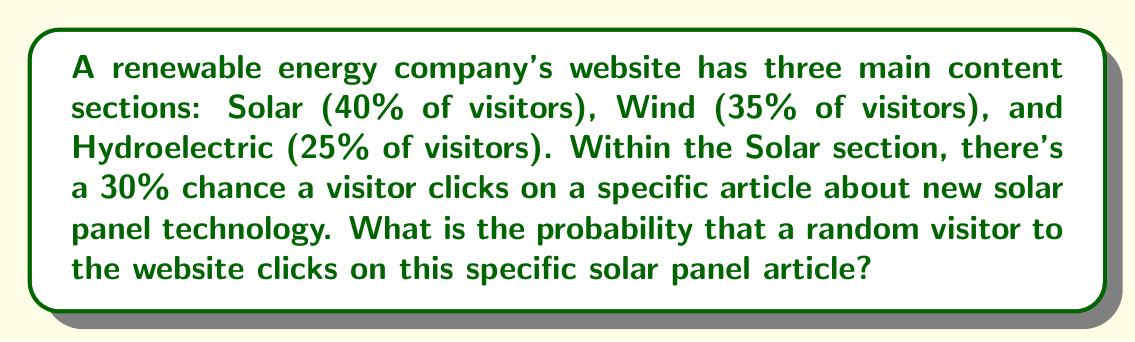Teach me how to tackle this problem. To solve this problem, we need to use the concept of conditional probability. Let's break it down step-by-step:

1. Define events:
   A: Visitor clicks on the specific solar panel article
   S: Visitor goes to the Solar section

2. We're given:
   P(S) = 40% = 0.40 (probability of visiting the Solar section)
   P(A|S) = 30% = 0.30 (probability of clicking the article given they're in the Solar section)

3. We need to find P(A), which can be calculated using the formula:
   $$P(A) = P(A|S) \cdot P(S)$$

4. Substitute the values:
   $$P(A) = 0.30 \cdot 0.40$$

5. Calculate:
   $$P(A) = 0.12$$

Therefore, the probability that a random visitor clicks on the specific solar panel article is 0.12 or 12%.
Answer: 0.12 